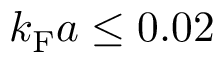Convert formula to latex. <formula><loc_0><loc_0><loc_500><loc_500>k _ { F } a \leq 0 . 0 2</formula> 